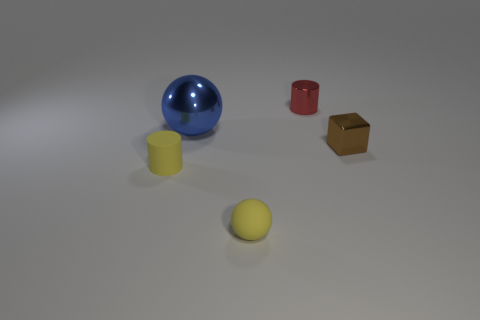What shape is the thing that is behind the yellow matte cylinder and in front of the large metallic thing?
Your answer should be compact. Cube. There is a object that is the same material as the small yellow cylinder; what is its color?
Offer a terse response. Yellow. Are there the same number of small yellow things to the left of the blue shiny thing and tiny red metal cylinders?
Your answer should be compact. Yes. What shape is the red shiny object that is the same size as the brown thing?
Ensure brevity in your answer.  Cylinder. What number of other objects are there of the same shape as the big object?
Offer a very short reply. 1. Does the blue thing have the same size as the yellow rubber object that is left of the shiny ball?
Offer a very short reply. No. What number of objects are metal objects right of the tiny yellow rubber ball or big blue metallic balls?
Your answer should be compact. 3. The shiny object left of the tiny red cylinder has what shape?
Provide a short and direct response. Sphere. Are there an equal number of yellow matte objects in front of the brown shiny block and brown blocks in front of the tiny rubber ball?
Your answer should be compact. No. There is a metallic thing that is to the right of the metallic sphere and behind the small block; what color is it?
Keep it short and to the point. Red. 